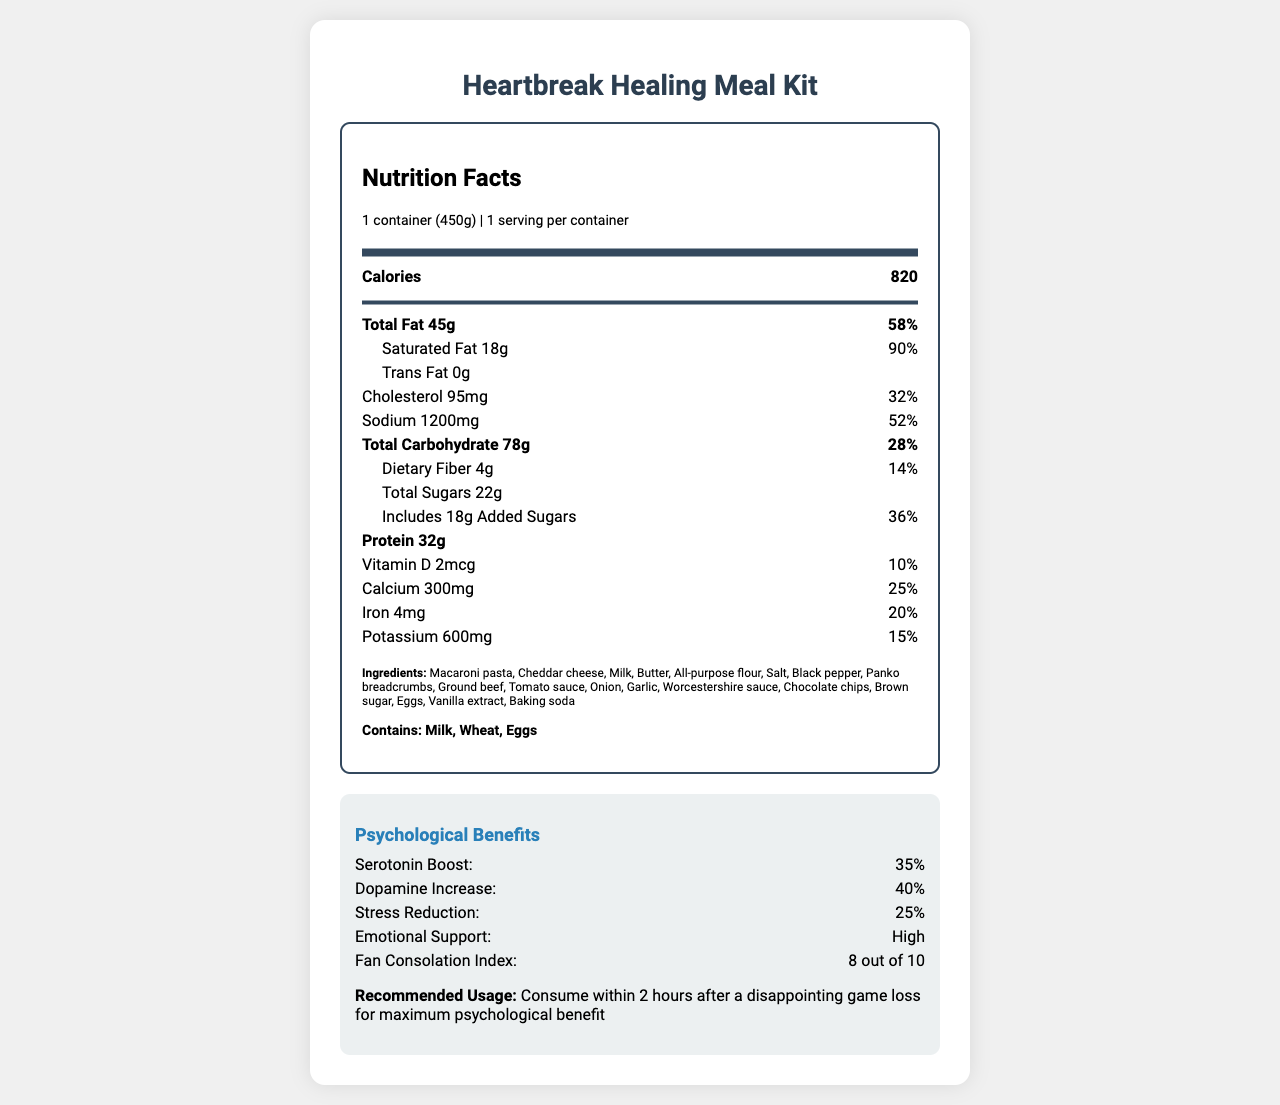what is the serving size? The serving size is mentioned near the top of the Nutrition Facts where it states serving size as 1 container (450g).
Answer: 1 container (450g) how many calories are in one container? The calorie count is listed prominently under the main info section.
Answer: 820 how much saturated fat does the meal kit contain? The amount of saturated fat is found in the indented row under the total fat section.
Answer: 18g what is the daily value percentage of sodium? The daily value percentage of sodium is listed next to the sodium amount.
Answer: 52% how much protein is in the Heartbreak Healing Meal Kit? The protein content is listed in bold toward the bottom of the main info section.
Answer: 32g which ingredient is NOT listed in the Heartbreak Healing Meal Kit? A. Milk B. Sugar C. Honey D. Butter The list of ingredients does not include honey, but it does include all the other listed options.
Answer: C. Honey what is the fan consolation index? A. 5 out of 10 B. 6 out of 10 C. 7 out of 10 D. 8 out of 10 The fan consolation index is listed under the psychological benefits section as "8 out of 10."
Answer: D. 8 out of 10 does the meal kit contain any allergens? The allergens section clearly states that the kit contains milk, wheat, and eggs.
Answer: Yes what are the psychological benefits listed for this meal kit? The psychological benefits section lists these specific benefits.
Answer: Serotonin boost, Dopamine increase, Stress reduction, Emotional support how much vitamin D does the meal kit provide as a percentage of daily value? The percentage of daily value for vitamin D is listed next to the amount of vitamin D.
Answer: 10% describe the main idea of the document This response summarizes all the key sections and information presented in the document.
Answer: The document details the nutritional information, ingredients, allergens, and psychological benefits of the Heartbreak Healing Meal Kit designed for baseball fans experiencing post-game disappointment. It lists serving size, calories, macronutrients, vitamins, minerals, and additional psychological effects, alongside usage recommendations. how likely is the meal kit to provide emotional support? Under the psychological benefits section, emotional support is specifically described as "High."
Answer: High what is the exact amount of calcium provided by the meal kit? The amount of calcium is listed in the nutrient breakdown section of the document.
Answer: 300mg what is the recommended usage for this meal kit? The recommended usage is stated in the psychological benefits section.
Answer: Consume within 2 hours after a disappointing game loss for maximum psychological benefit what are the serotonin boost and dopamine increase percentages? These percentages are specifically listed in the psychological benefits section.
Answer: Serotonin boost: 35%, Dopamine increase: 40% how many allergens are listed for this meal kit? The allergens section lists milk, wheat, and eggs, which totals three allergens.
Answer: 3 what ingredient makes up the bulk of the "comfort food" meal kit? The document lists all the ingredients, but it does not specify the quantities or proportions of each ingredient, so we cannot determine which makes up the bulk.
Answer: Cannot be determined 